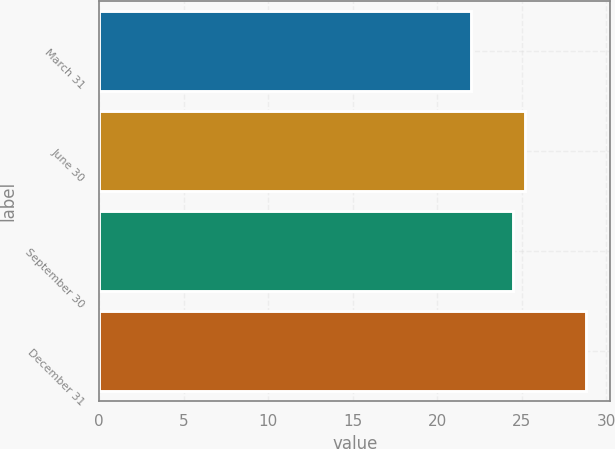<chart> <loc_0><loc_0><loc_500><loc_500><bar_chart><fcel>March 31<fcel>June 30<fcel>September 30<fcel>December 31<nl><fcel>22<fcel>25.18<fcel>24.5<fcel>28.8<nl></chart> 